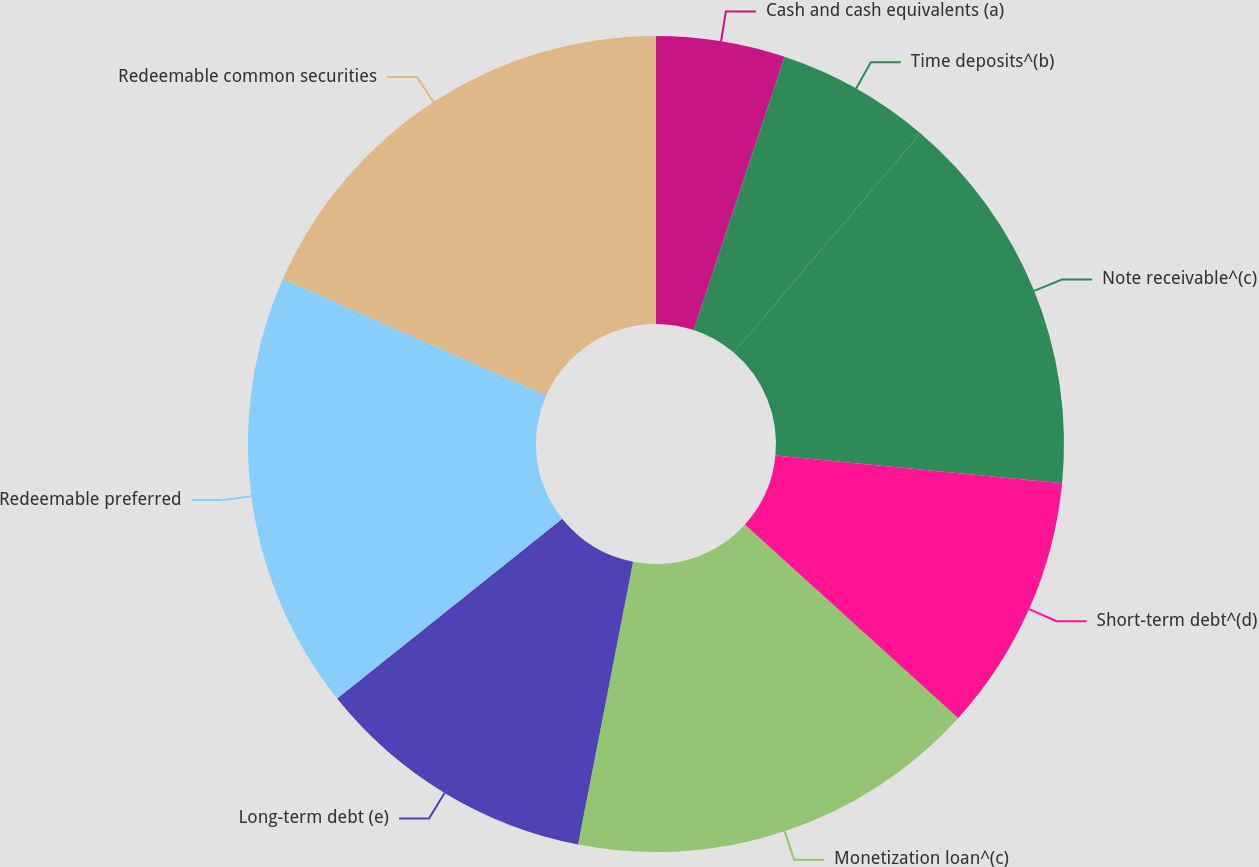Convert chart to OTSL. <chart><loc_0><loc_0><loc_500><loc_500><pie_chart><fcel>Cash and cash equivalents (a)<fcel>Time deposits^(b)<fcel>Note receivable^(c)<fcel>Short-term debt^(d)<fcel>Monetization loan^(c)<fcel>Long-term debt (e)<fcel>Redeemable preferred<fcel>Redeemable common securities<nl><fcel>5.1%<fcel>6.12%<fcel>15.31%<fcel>10.2%<fcel>16.33%<fcel>11.22%<fcel>17.35%<fcel>18.37%<nl></chart> 